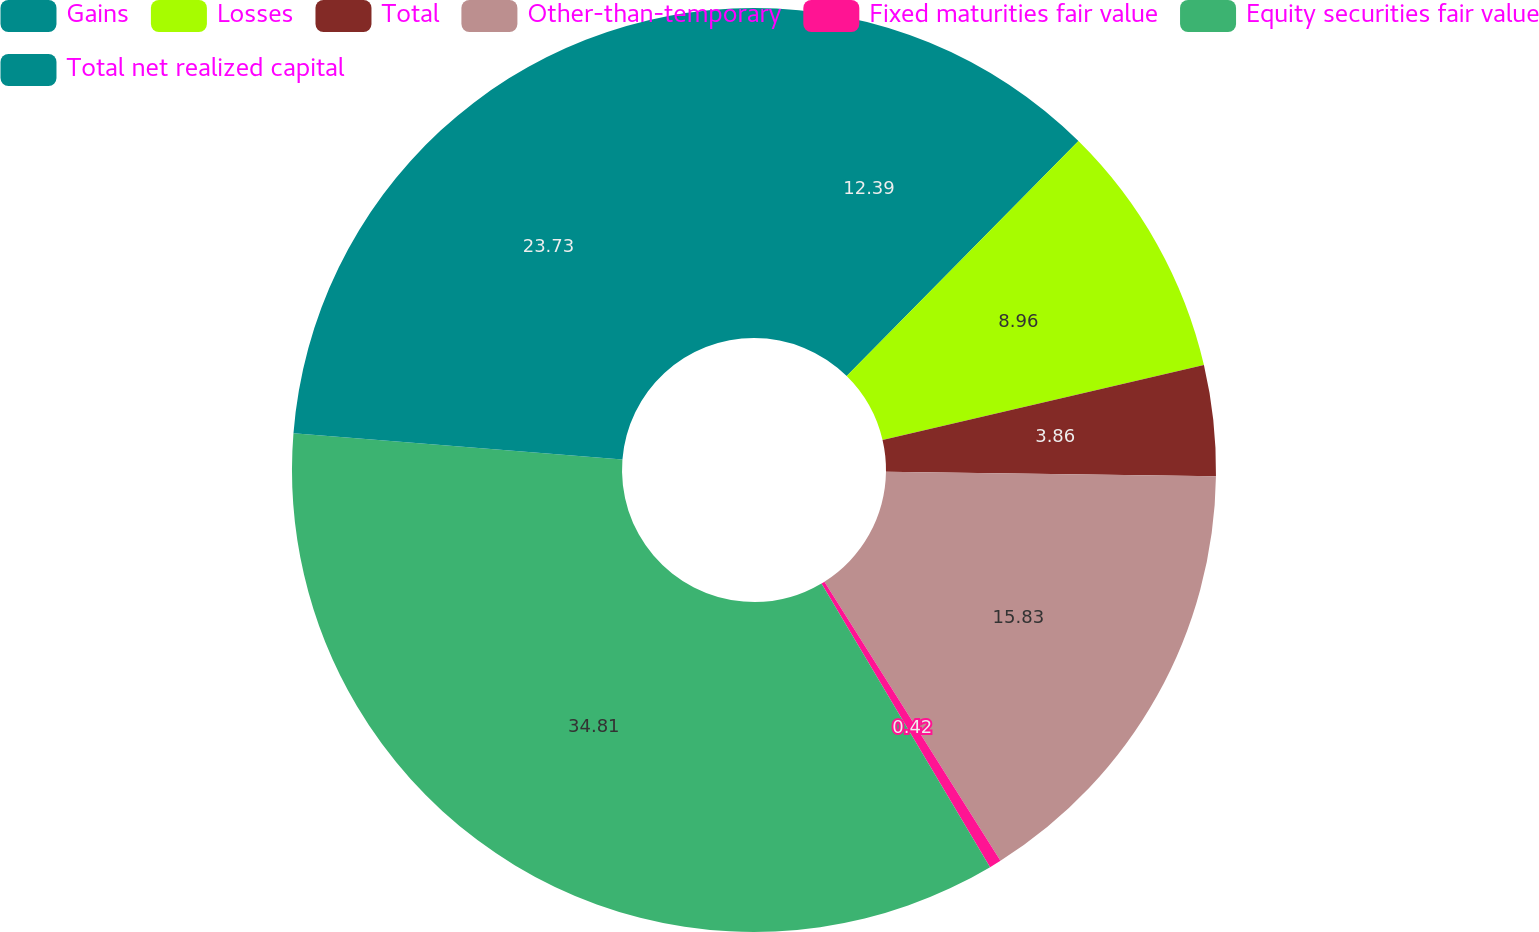Convert chart to OTSL. <chart><loc_0><loc_0><loc_500><loc_500><pie_chart><fcel>Gains<fcel>Losses<fcel>Total<fcel>Other-than-temporary<fcel>Fixed maturities fair value<fcel>Equity securities fair value<fcel>Total net realized capital<nl><fcel>12.39%<fcel>8.96%<fcel>3.86%<fcel>15.83%<fcel>0.42%<fcel>34.8%<fcel>23.73%<nl></chart> 